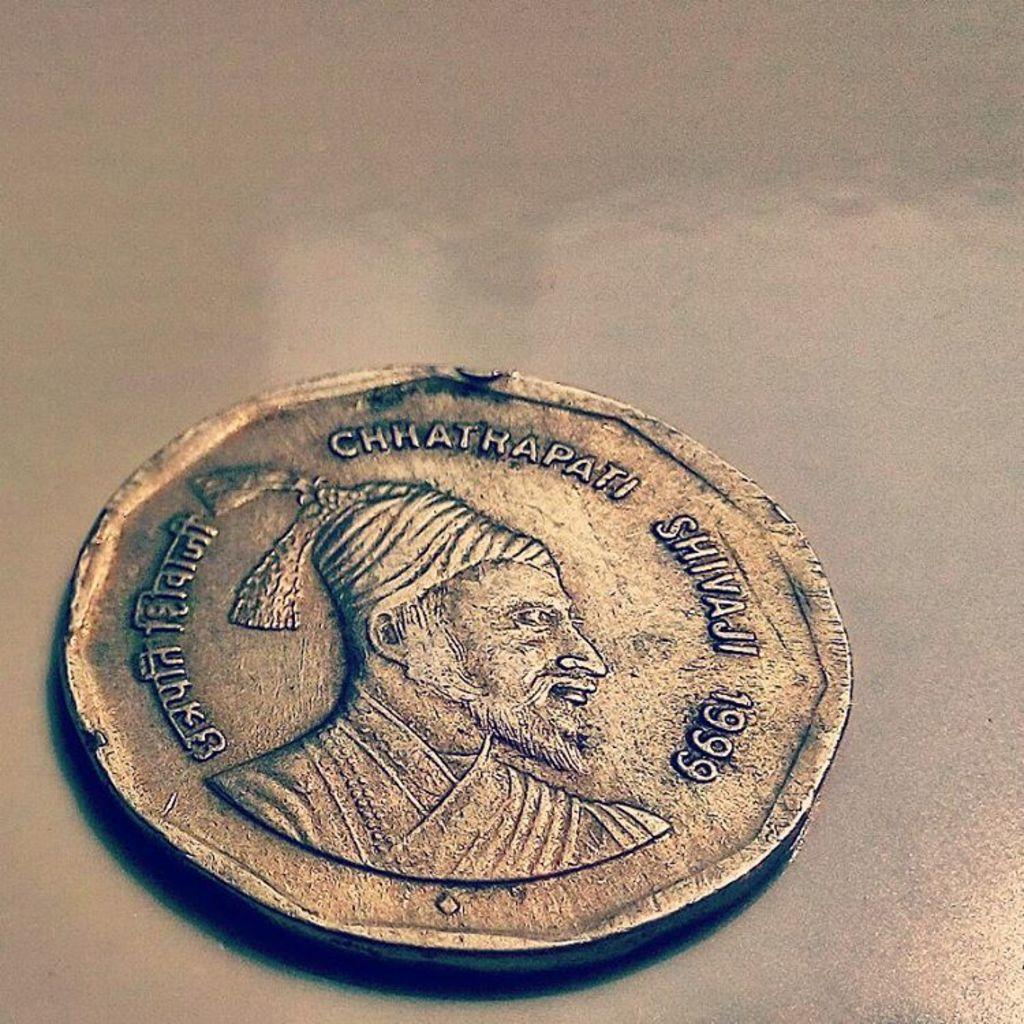Provide a one-sentence caption for the provided image. A small gold coin from a foreign country from the year 1999. 